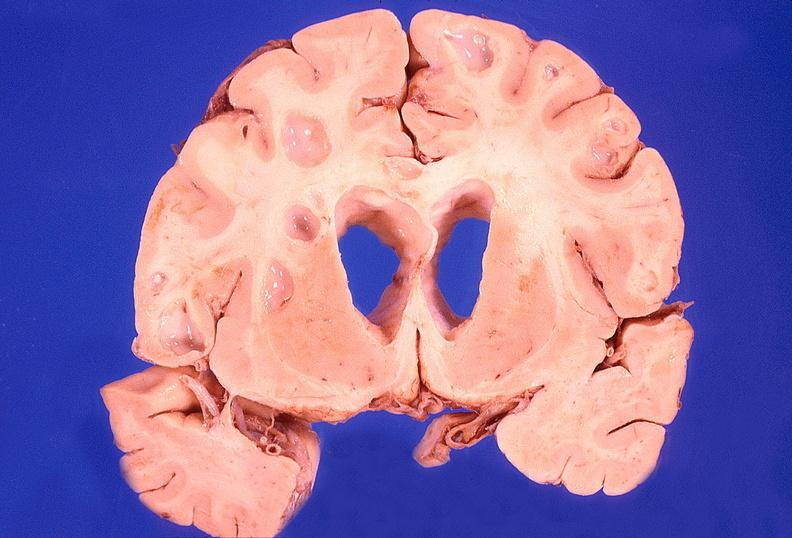what does this image show?
Answer the question using a single word or phrase. Brain abscess 